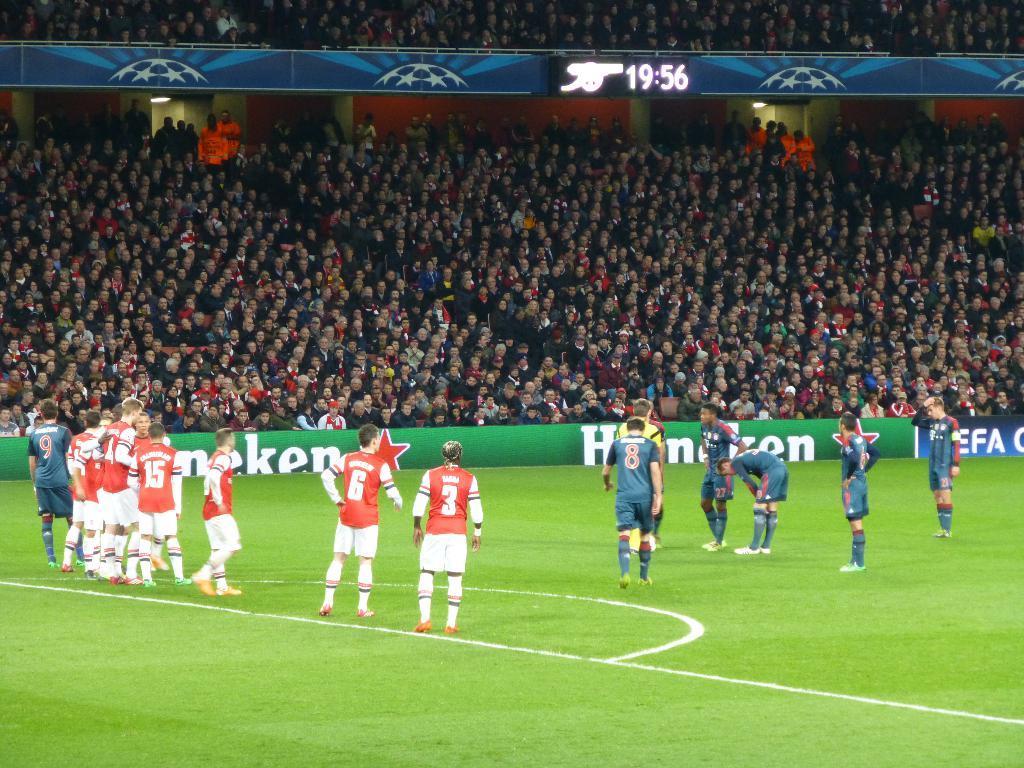In one or two sentences, can you explain what this image depicts? In the picture I can see a group of people among them some are standing and other people are sitting on chairs. I can also see fence, the grass and white color lines on the ground. 